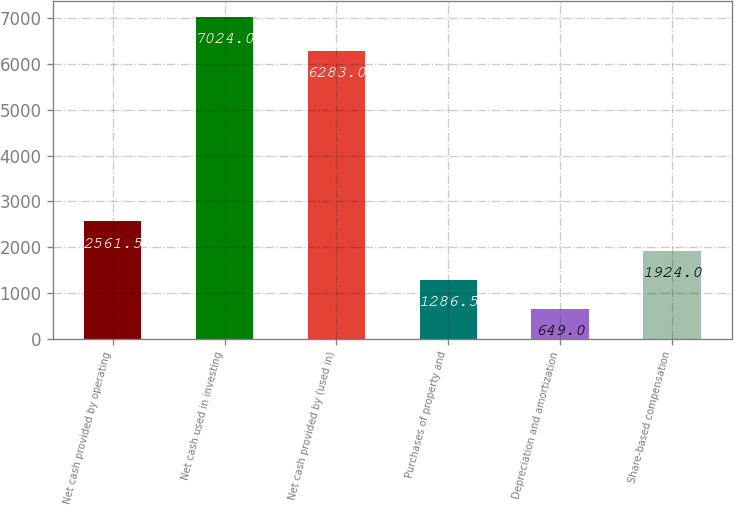Convert chart to OTSL. <chart><loc_0><loc_0><loc_500><loc_500><bar_chart><fcel>Net cash provided by operating<fcel>Net cash used in investing<fcel>Net cash provided by (used in)<fcel>Purchases of property and<fcel>Depreciation and amortization<fcel>Share-based compensation<nl><fcel>2561.5<fcel>7024<fcel>6283<fcel>1286.5<fcel>649<fcel>1924<nl></chart> 